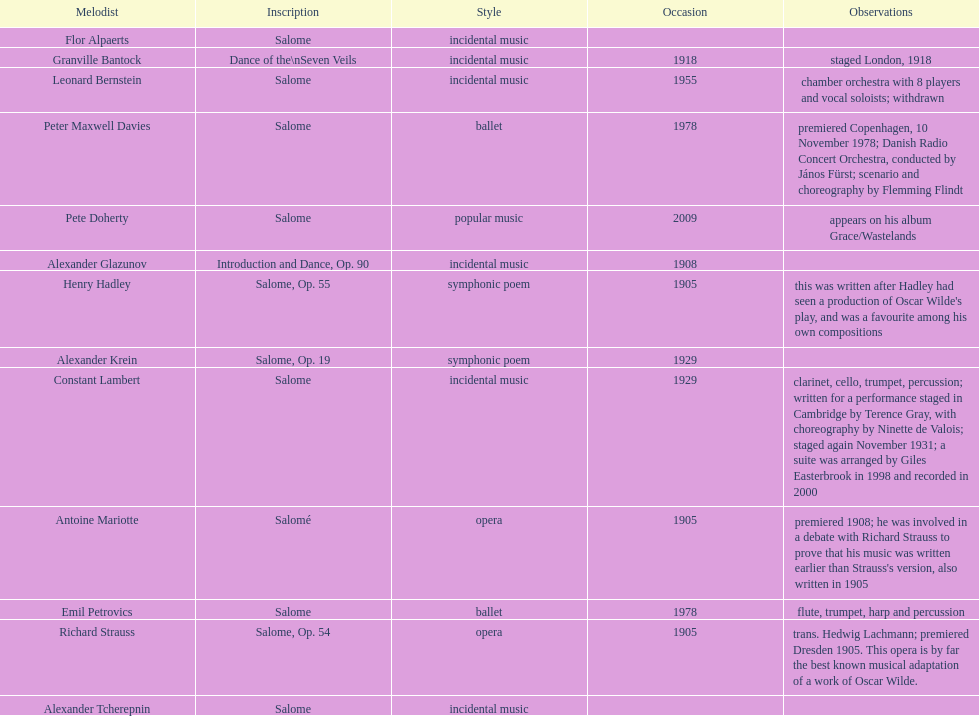Can you give me this table as a dict? {'header': ['Melodist', 'Inscription', 'Style', 'Occasion', 'Observations'], 'rows': [['Flor Alpaerts', 'Salome', 'incidental\xa0music', '', ''], ['Granville Bantock', 'Dance of the\\nSeven Veils', 'incidental music', '1918', 'staged London, 1918'], ['Leonard Bernstein', 'Salome', 'incidental music', '1955', 'chamber orchestra with 8 players and vocal soloists; withdrawn'], ['Peter\xa0Maxwell\xa0Davies', 'Salome', 'ballet', '1978', 'premiered Copenhagen, 10 November 1978; Danish Radio Concert Orchestra, conducted by János Fürst; scenario and choreography by Flemming Flindt'], ['Pete Doherty', 'Salome', 'popular music', '2009', 'appears on his album Grace/Wastelands'], ['Alexander Glazunov', 'Introduction and Dance, Op. 90', 'incidental music', '1908', ''], ['Henry Hadley', 'Salome, Op. 55', 'symphonic poem', '1905', "this was written after Hadley had seen a production of Oscar Wilde's play, and was a favourite among his own compositions"], ['Alexander Krein', 'Salome, Op. 19', 'symphonic poem', '1929', ''], ['Constant Lambert', 'Salome', 'incidental music', '1929', 'clarinet, cello, trumpet, percussion; written for a performance staged in Cambridge by Terence Gray, with choreography by Ninette de Valois; staged again November 1931; a suite was arranged by Giles Easterbrook in 1998 and recorded in 2000'], ['Antoine Mariotte', 'Salomé', 'opera', '1905', "premiered 1908; he was involved in a debate with Richard Strauss to prove that his music was written earlier than Strauss's version, also written in 1905"], ['Emil Petrovics', 'Salome', 'ballet', '1978', 'flute, trumpet, harp and percussion'], ['Richard Strauss', 'Salome, Op. 54', 'opera', '1905', 'trans. Hedwig Lachmann; premiered Dresden 1905. This opera is by far the best known musical adaptation of a work of Oscar Wilde.'], ['Alexander\xa0Tcherepnin', 'Salome', 'incidental music', '', '']]} Why type of genre was peter maxwell davies' work that was the same as emil petrovics' Ballet. 